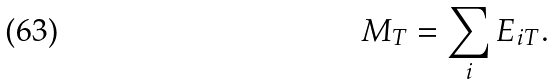<formula> <loc_0><loc_0><loc_500><loc_500>M _ { T } = \sum _ { i } E _ { i T } .</formula> 